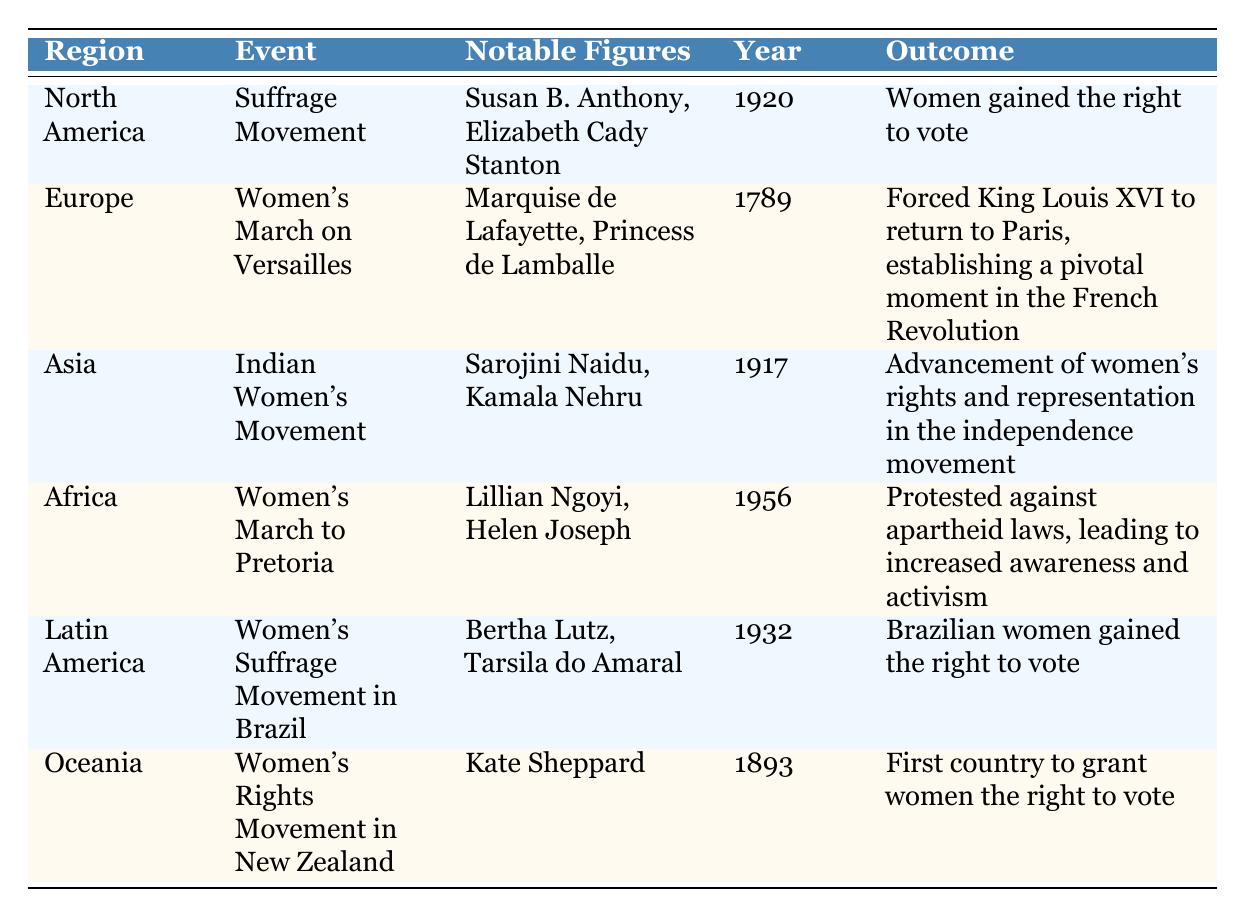What event marked the beginning of women's suffrage in North America? The table specifies that the event is the Suffrage Movement, which took place in North America, leading to women gaining the right to vote.
Answer: Suffrage Movement Which notable figures are associated with the Women's March on Versailles in Europe? According to the table, the notable figures mentioned for this event are Marquise de Lafayette and Princess de Lamballe.
Answer: Marquise de Lafayette, Princess de Lamballe In which year did Brazilian women gain the right to vote? The table indicates that Brazilian women gained the right to vote in the year 1932, during the Women's Suffrage Movement in Brazil.
Answer: 1932 Did the Women's March to Pretoria occur before or after the Indian Women's Movement? The Women's March to Pretoria took place in 1956, while the Indian Women's Movement occurred in 1917, indicating that the former was after the latter.
Answer: After Which region's women were the first to gain the right to vote and in what year? The table shows that women in Oceania, specifically New Zealand, were the first to gain the right to vote in 1893, making it the earliest representation of women's voting rights in the table.
Answer: Oceania, 1893 How many events listed in the table occurred in the 20th century? The events occurring in the 20th century are the Suffrage Movement in 1920, the Indian Women's Movement in 1917, and the Women's Suffrage Movement in Brazil in 1932. Therefore, there are three events from the 20th century.
Answer: 3 Which event resulted in women gaining representations in the independence movement? The Indian Women's Movement in 1917 is noted for leading to the advancement of women's rights and representation in the independence movement.
Answer: Indian Women's Movement Is the Women's Rights Movement in New Zealand the only event listed that occurred in the 19th century? Yes, according to the table, the Women's Rights Movement in New Zealand occurred in 1893, and it is the only event from the 19th century present in the data.
Answer: Yes What was the outcome of the Women's March to Pretoria? The outcome listed for the Women's March to Pretoria in 1956 was that it led to increased awareness and activism against apartheid laws.
Answer: Increased awareness and activism against apartheid laws 